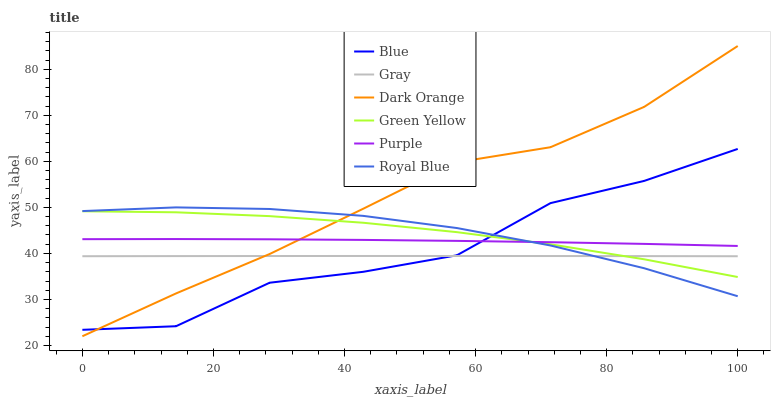Does Gray have the minimum area under the curve?
Answer yes or no. Yes. Does Dark Orange have the maximum area under the curve?
Answer yes or no. Yes. Does Dark Orange have the minimum area under the curve?
Answer yes or no. No. Does Gray have the maximum area under the curve?
Answer yes or no. No. Is Gray the smoothest?
Answer yes or no. Yes. Is Blue the roughest?
Answer yes or no. Yes. Is Dark Orange the smoothest?
Answer yes or no. No. Is Dark Orange the roughest?
Answer yes or no. No. Does Gray have the lowest value?
Answer yes or no. No. Does Dark Orange have the highest value?
Answer yes or no. Yes. Does Gray have the highest value?
Answer yes or no. No. Is Gray less than Purple?
Answer yes or no. Yes. Is Purple greater than Gray?
Answer yes or no. Yes. Does Royal Blue intersect Dark Orange?
Answer yes or no. Yes. Is Royal Blue less than Dark Orange?
Answer yes or no. No. Is Royal Blue greater than Dark Orange?
Answer yes or no. No. Does Gray intersect Purple?
Answer yes or no. No. 